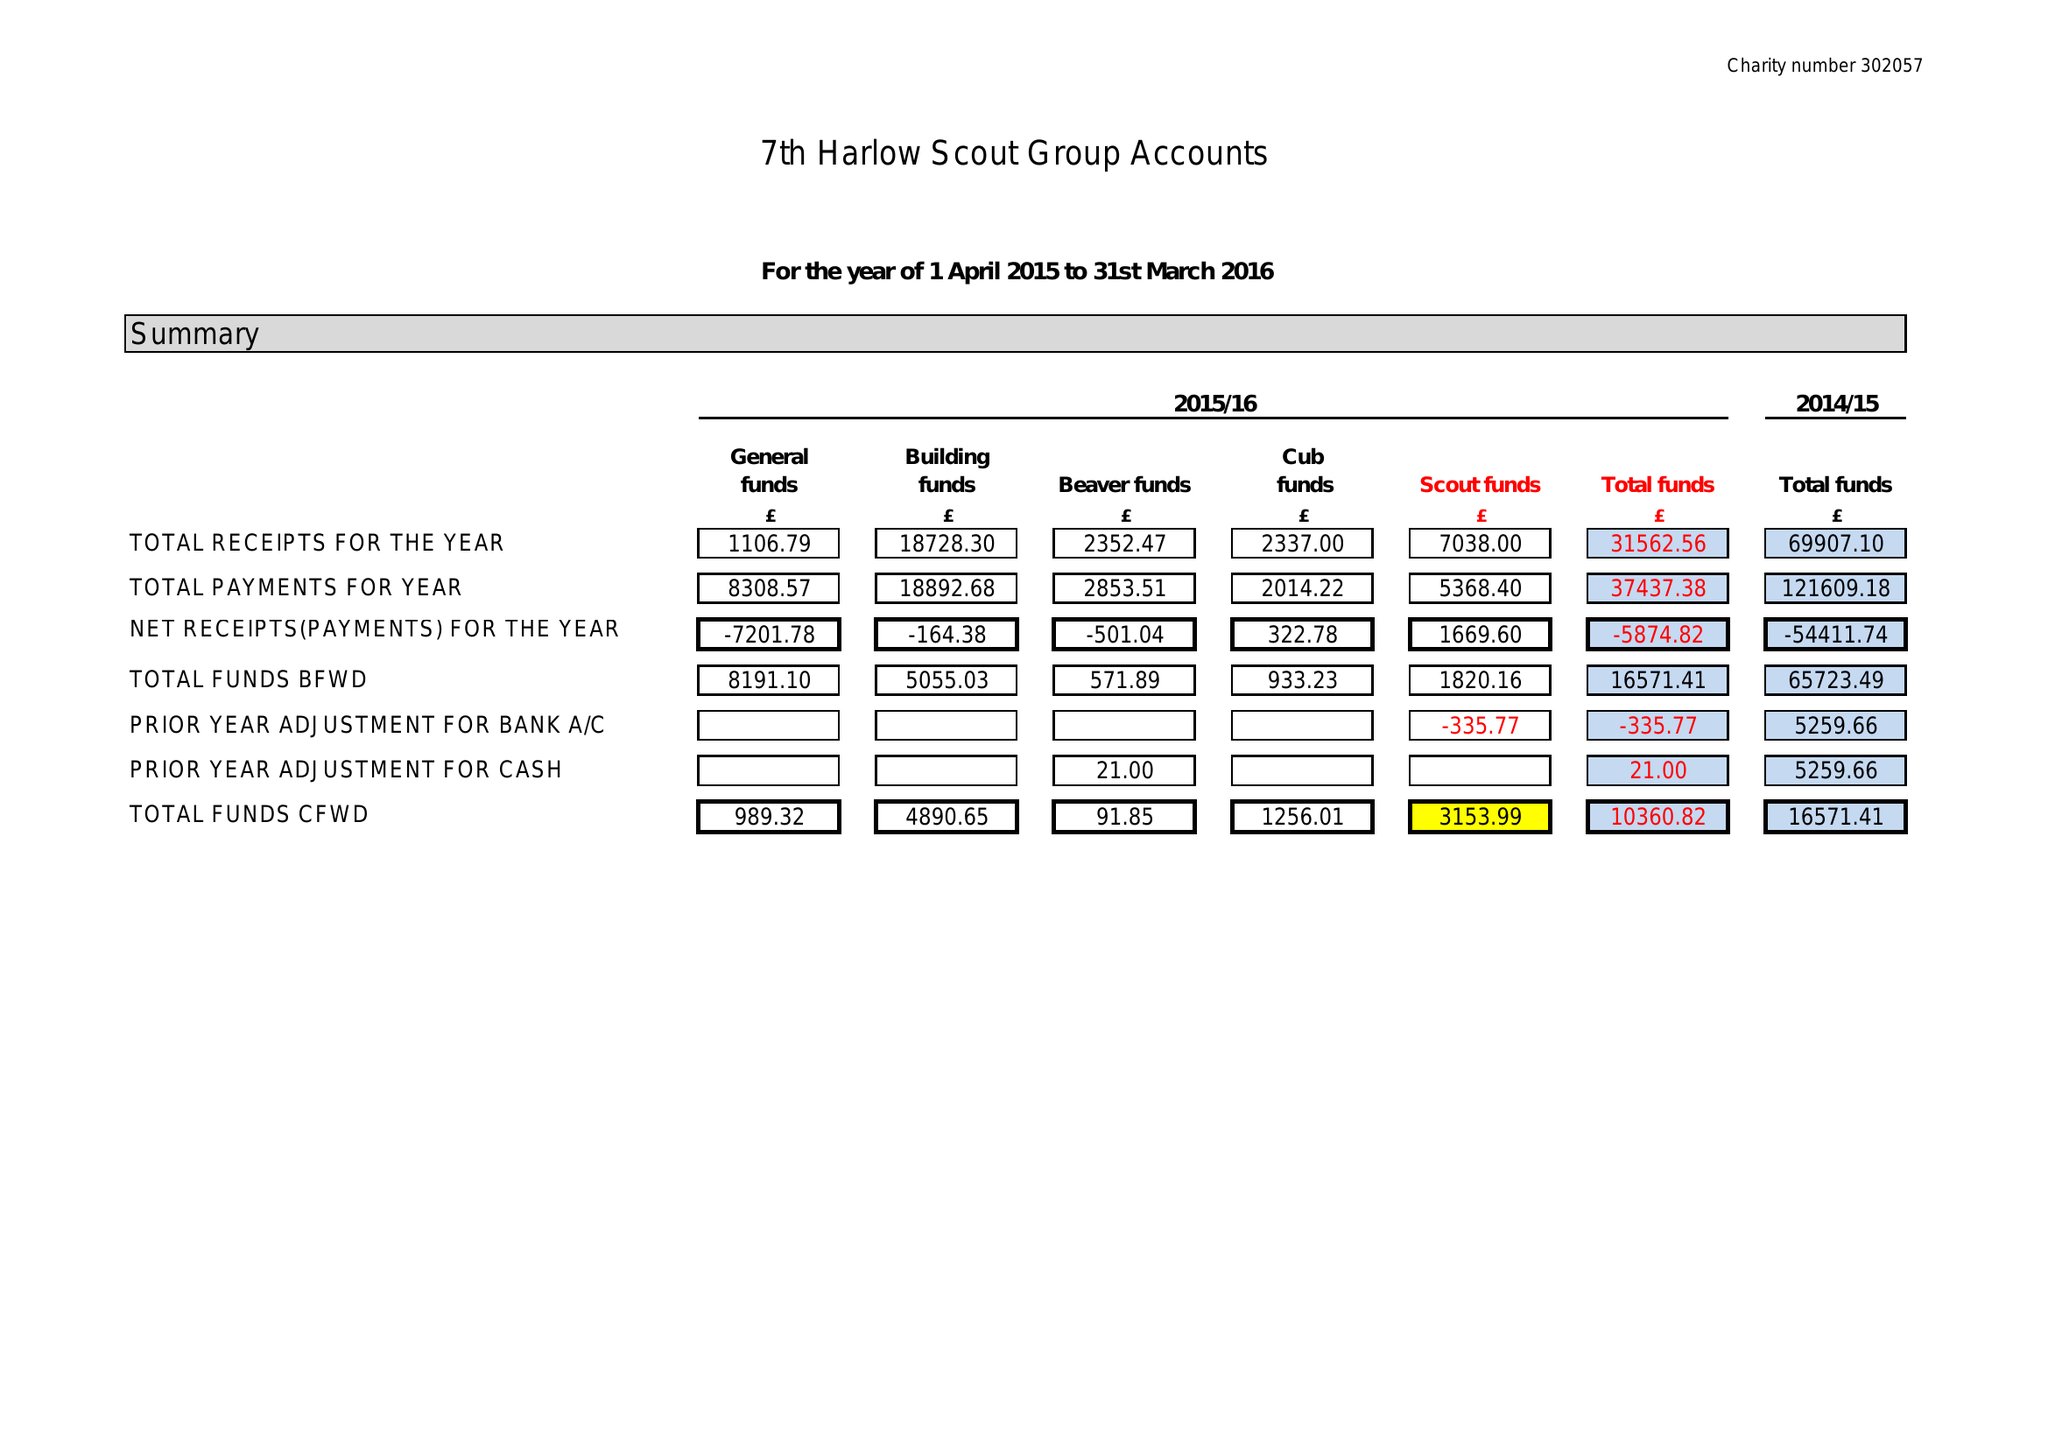What is the value for the charity_number?
Answer the question using a single word or phrase. 302057 